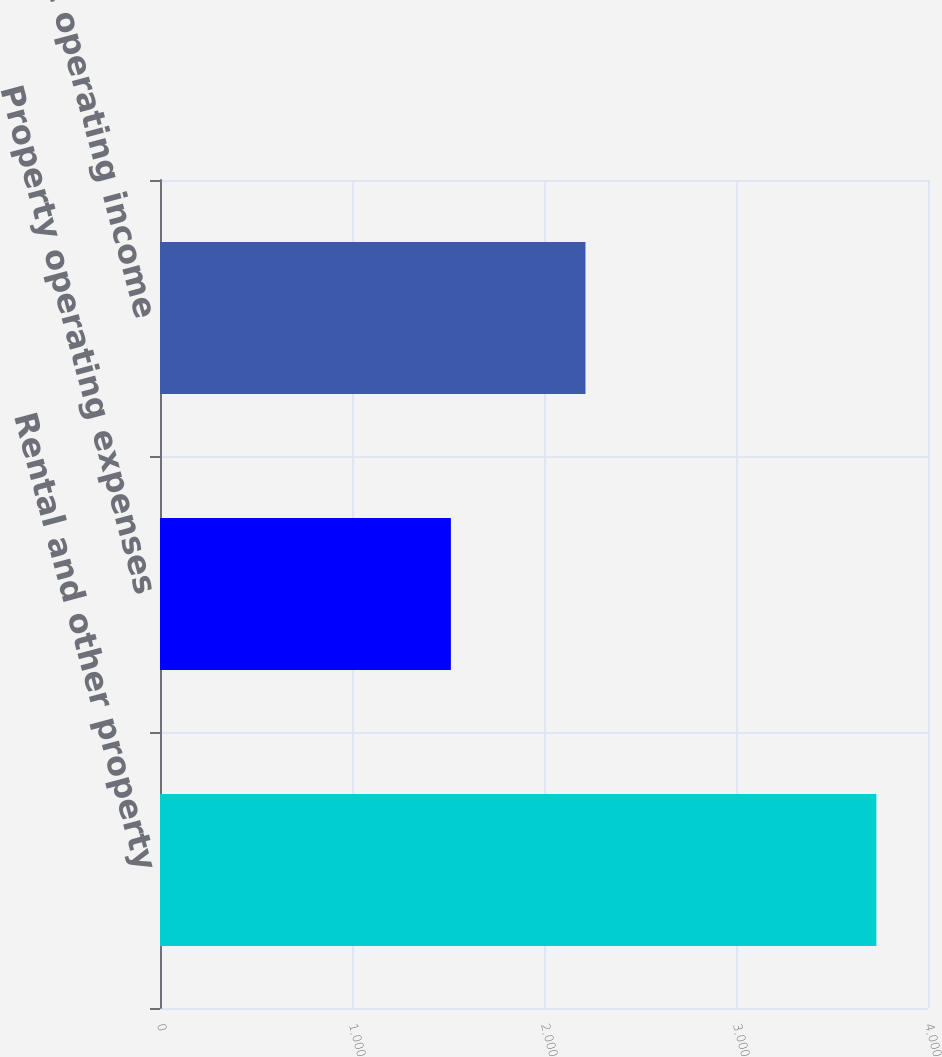Convert chart to OTSL. <chart><loc_0><loc_0><loc_500><loc_500><bar_chart><fcel>Rental and other property<fcel>Property operating expenses<fcel>Property net operating income<nl><fcel>3731<fcel>1515<fcel>2216<nl></chart> 